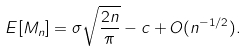<formula> <loc_0><loc_0><loc_500><loc_500>E [ M _ { n } ] = \sigma \sqrt { \frac { 2 n } { \pi } } - c + O ( n ^ { - 1 / 2 } ) .</formula> 